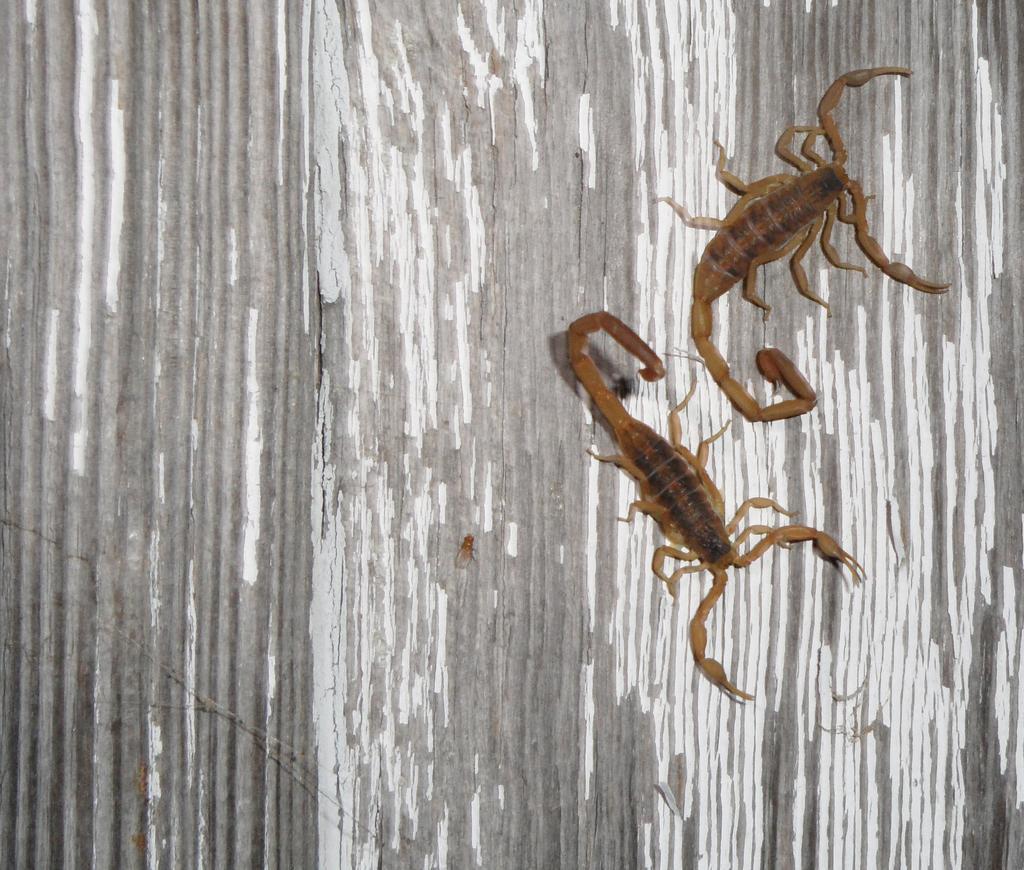Describe this image in one or two sentences. In this image we can see two scorpions on the grey and white color surface. 